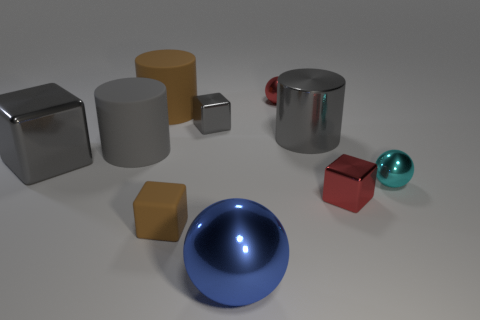What number of other objects are there of the same material as the cyan thing?
Ensure brevity in your answer.  6. What material is the big brown thing?
Your answer should be very brief. Rubber. There is a cylinder right of the large blue metallic object; how big is it?
Offer a terse response. Large. What number of gray metal cylinders are behind the gray block that is in front of the small gray metal cube?
Give a very brief answer. 1. Does the big blue thing that is in front of the small gray metallic block have the same shape as the red metal object that is behind the small gray cube?
Provide a short and direct response. Yes. How many objects are behind the red block and on the left side of the cyan shiny thing?
Offer a terse response. 6. Is there a big cylinder that has the same color as the small matte cube?
Your answer should be compact. Yes. What shape is the matte object that is the same size as the brown cylinder?
Give a very brief answer. Cylinder. There is a big brown cylinder; are there any matte things right of it?
Provide a succinct answer. Yes. Are the big ball in front of the big brown thing and the tiny red thing to the left of the tiny red metal block made of the same material?
Offer a terse response. Yes. 